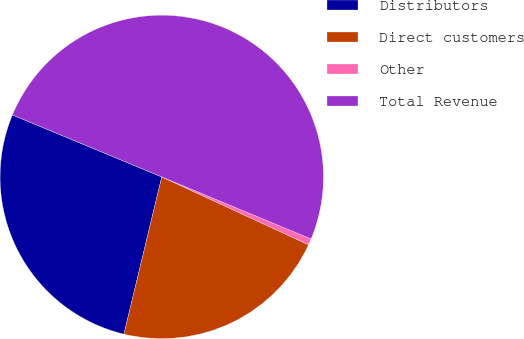Convert chart to OTSL. <chart><loc_0><loc_0><loc_500><loc_500><pie_chart><fcel>Distributors<fcel>Direct customers<fcel>Other<fcel>Total Revenue<nl><fcel>27.5%<fcel>21.86%<fcel>0.63%<fcel>50.0%<nl></chart> 